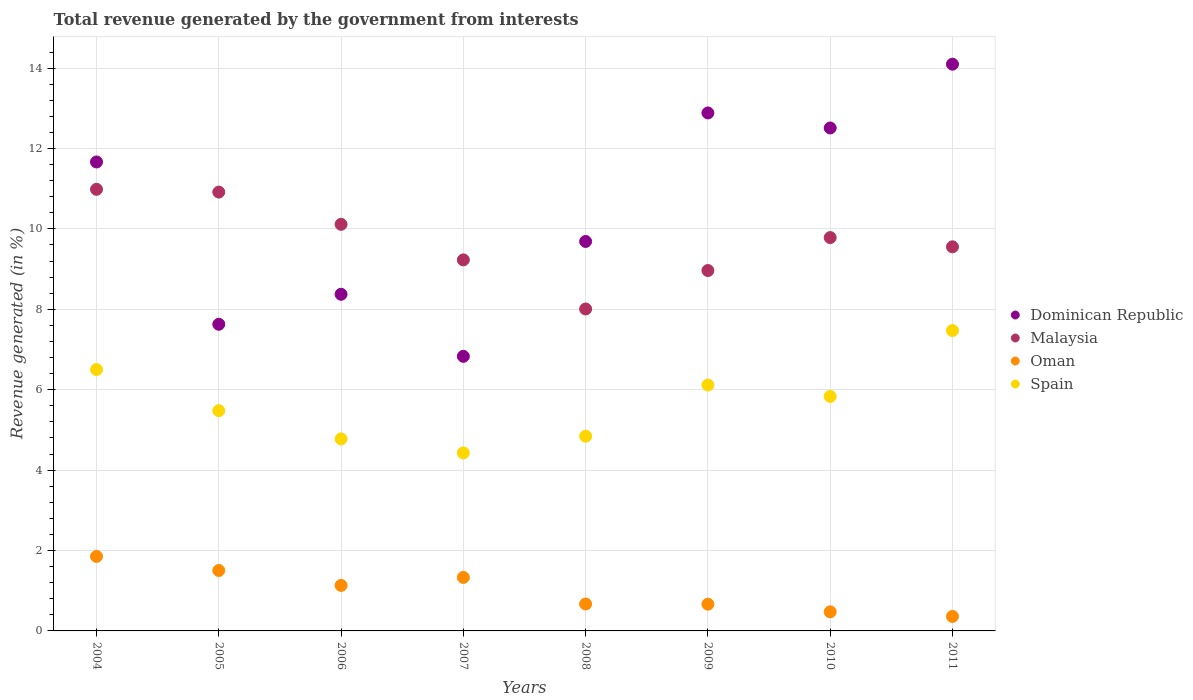How many different coloured dotlines are there?
Give a very brief answer. 4. What is the total revenue generated in Dominican Republic in 2009?
Offer a very short reply. 12.88. Across all years, what is the maximum total revenue generated in Oman?
Your answer should be compact. 1.85. Across all years, what is the minimum total revenue generated in Malaysia?
Provide a succinct answer. 8.01. What is the total total revenue generated in Dominican Republic in the graph?
Offer a terse response. 83.68. What is the difference between the total revenue generated in Dominican Republic in 2005 and that in 2011?
Your answer should be very brief. -6.47. What is the difference between the total revenue generated in Spain in 2006 and the total revenue generated in Malaysia in 2008?
Ensure brevity in your answer.  -3.23. What is the average total revenue generated in Oman per year?
Provide a succinct answer. 1. In the year 2008, what is the difference between the total revenue generated in Malaysia and total revenue generated in Spain?
Give a very brief answer. 3.16. What is the ratio of the total revenue generated in Spain in 2004 to that in 2008?
Offer a very short reply. 1.34. Is the total revenue generated in Spain in 2004 less than that in 2010?
Keep it short and to the point. No. Is the difference between the total revenue generated in Malaysia in 2006 and 2011 greater than the difference between the total revenue generated in Spain in 2006 and 2011?
Provide a succinct answer. Yes. What is the difference between the highest and the second highest total revenue generated in Dominican Republic?
Your answer should be compact. 1.21. What is the difference between the highest and the lowest total revenue generated in Spain?
Keep it short and to the point. 3.04. In how many years, is the total revenue generated in Spain greater than the average total revenue generated in Spain taken over all years?
Offer a very short reply. 4. How many dotlines are there?
Your response must be concise. 4. What is the difference between two consecutive major ticks on the Y-axis?
Provide a short and direct response. 2. Does the graph contain grids?
Your response must be concise. Yes. Where does the legend appear in the graph?
Ensure brevity in your answer.  Center right. How many legend labels are there?
Provide a short and direct response. 4. How are the legend labels stacked?
Ensure brevity in your answer.  Vertical. What is the title of the graph?
Make the answer very short. Total revenue generated by the government from interests. Does "Nicaragua" appear as one of the legend labels in the graph?
Ensure brevity in your answer.  No. What is the label or title of the Y-axis?
Provide a succinct answer. Revenue generated (in %). What is the Revenue generated (in %) in Dominican Republic in 2004?
Offer a terse response. 11.67. What is the Revenue generated (in %) of Malaysia in 2004?
Offer a very short reply. 10.99. What is the Revenue generated (in %) of Oman in 2004?
Provide a succinct answer. 1.85. What is the Revenue generated (in %) of Spain in 2004?
Provide a succinct answer. 6.5. What is the Revenue generated (in %) of Dominican Republic in 2005?
Offer a very short reply. 7.63. What is the Revenue generated (in %) in Malaysia in 2005?
Provide a short and direct response. 10.92. What is the Revenue generated (in %) of Oman in 2005?
Your answer should be compact. 1.5. What is the Revenue generated (in %) of Spain in 2005?
Your response must be concise. 5.48. What is the Revenue generated (in %) in Dominican Republic in 2006?
Your response must be concise. 8.37. What is the Revenue generated (in %) of Malaysia in 2006?
Provide a short and direct response. 10.11. What is the Revenue generated (in %) in Oman in 2006?
Keep it short and to the point. 1.13. What is the Revenue generated (in %) in Spain in 2006?
Keep it short and to the point. 4.78. What is the Revenue generated (in %) in Dominican Republic in 2007?
Ensure brevity in your answer.  6.83. What is the Revenue generated (in %) of Malaysia in 2007?
Keep it short and to the point. 9.23. What is the Revenue generated (in %) in Oman in 2007?
Provide a short and direct response. 1.33. What is the Revenue generated (in %) in Spain in 2007?
Your answer should be compact. 4.43. What is the Revenue generated (in %) in Dominican Republic in 2008?
Keep it short and to the point. 9.69. What is the Revenue generated (in %) of Malaysia in 2008?
Your answer should be compact. 8.01. What is the Revenue generated (in %) of Oman in 2008?
Keep it short and to the point. 0.67. What is the Revenue generated (in %) in Spain in 2008?
Offer a very short reply. 4.84. What is the Revenue generated (in %) of Dominican Republic in 2009?
Provide a succinct answer. 12.88. What is the Revenue generated (in %) in Malaysia in 2009?
Give a very brief answer. 8.96. What is the Revenue generated (in %) of Oman in 2009?
Your answer should be compact. 0.66. What is the Revenue generated (in %) of Spain in 2009?
Your answer should be compact. 6.12. What is the Revenue generated (in %) of Dominican Republic in 2010?
Your answer should be compact. 12.51. What is the Revenue generated (in %) in Malaysia in 2010?
Your answer should be compact. 9.78. What is the Revenue generated (in %) in Oman in 2010?
Provide a short and direct response. 0.47. What is the Revenue generated (in %) in Spain in 2010?
Give a very brief answer. 5.83. What is the Revenue generated (in %) in Dominican Republic in 2011?
Offer a very short reply. 14.1. What is the Revenue generated (in %) of Malaysia in 2011?
Make the answer very short. 9.55. What is the Revenue generated (in %) of Oman in 2011?
Ensure brevity in your answer.  0.36. What is the Revenue generated (in %) of Spain in 2011?
Offer a very short reply. 7.47. Across all years, what is the maximum Revenue generated (in %) of Dominican Republic?
Offer a terse response. 14.1. Across all years, what is the maximum Revenue generated (in %) in Malaysia?
Provide a succinct answer. 10.99. Across all years, what is the maximum Revenue generated (in %) in Oman?
Give a very brief answer. 1.85. Across all years, what is the maximum Revenue generated (in %) of Spain?
Offer a very short reply. 7.47. Across all years, what is the minimum Revenue generated (in %) of Dominican Republic?
Make the answer very short. 6.83. Across all years, what is the minimum Revenue generated (in %) in Malaysia?
Provide a short and direct response. 8.01. Across all years, what is the minimum Revenue generated (in %) of Oman?
Give a very brief answer. 0.36. Across all years, what is the minimum Revenue generated (in %) in Spain?
Provide a short and direct response. 4.43. What is the total Revenue generated (in %) of Dominican Republic in the graph?
Your response must be concise. 83.68. What is the total Revenue generated (in %) of Malaysia in the graph?
Give a very brief answer. 77.56. What is the total Revenue generated (in %) of Oman in the graph?
Make the answer very short. 7.99. What is the total Revenue generated (in %) in Spain in the graph?
Your response must be concise. 45.45. What is the difference between the Revenue generated (in %) of Dominican Republic in 2004 and that in 2005?
Provide a succinct answer. 4.04. What is the difference between the Revenue generated (in %) in Malaysia in 2004 and that in 2005?
Make the answer very short. 0.07. What is the difference between the Revenue generated (in %) in Oman in 2004 and that in 2005?
Keep it short and to the point. 0.35. What is the difference between the Revenue generated (in %) in Spain in 2004 and that in 2005?
Keep it short and to the point. 1.02. What is the difference between the Revenue generated (in %) of Dominican Republic in 2004 and that in 2006?
Offer a terse response. 3.29. What is the difference between the Revenue generated (in %) in Malaysia in 2004 and that in 2006?
Your answer should be compact. 0.87. What is the difference between the Revenue generated (in %) in Oman in 2004 and that in 2006?
Provide a short and direct response. 0.72. What is the difference between the Revenue generated (in %) in Spain in 2004 and that in 2006?
Provide a short and direct response. 1.73. What is the difference between the Revenue generated (in %) of Dominican Republic in 2004 and that in 2007?
Your answer should be very brief. 4.83. What is the difference between the Revenue generated (in %) of Malaysia in 2004 and that in 2007?
Your answer should be compact. 1.76. What is the difference between the Revenue generated (in %) in Oman in 2004 and that in 2007?
Your response must be concise. 0.52. What is the difference between the Revenue generated (in %) in Spain in 2004 and that in 2007?
Keep it short and to the point. 2.07. What is the difference between the Revenue generated (in %) in Dominican Republic in 2004 and that in 2008?
Offer a very short reply. 1.98. What is the difference between the Revenue generated (in %) of Malaysia in 2004 and that in 2008?
Offer a terse response. 2.98. What is the difference between the Revenue generated (in %) in Oman in 2004 and that in 2008?
Provide a succinct answer. 1.18. What is the difference between the Revenue generated (in %) in Spain in 2004 and that in 2008?
Make the answer very short. 1.66. What is the difference between the Revenue generated (in %) in Dominican Republic in 2004 and that in 2009?
Your answer should be very brief. -1.22. What is the difference between the Revenue generated (in %) of Malaysia in 2004 and that in 2009?
Provide a short and direct response. 2.02. What is the difference between the Revenue generated (in %) of Oman in 2004 and that in 2009?
Keep it short and to the point. 1.19. What is the difference between the Revenue generated (in %) of Spain in 2004 and that in 2009?
Provide a succinct answer. 0.38. What is the difference between the Revenue generated (in %) of Dominican Republic in 2004 and that in 2010?
Provide a short and direct response. -0.85. What is the difference between the Revenue generated (in %) in Malaysia in 2004 and that in 2010?
Provide a succinct answer. 1.2. What is the difference between the Revenue generated (in %) of Oman in 2004 and that in 2010?
Provide a short and direct response. 1.38. What is the difference between the Revenue generated (in %) of Spain in 2004 and that in 2010?
Provide a short and direct response. 0.67. What is the difference between the Revenue generated (in %) in Dominican Republic in 2004 and that in 2011?
Provide a short and direct response. -2.43. What is the difference between the Revenue generated (in %) of Malaysia in 2004 and that in 2011?
Keep it short and to the point. 1.43. What is the difference between the Revenue generated (in %) of Oman in 2004 and that in 2011?
Provide a short and direct response. 1.49. What is the difference between the Revenue generated (in %) in Spain in 2004 and that in 2011?
Offer a very short reply. -0.97. What is the difference between the Revenue generated (in %) of Dominican Republic in 2005 and that in 2006?
Provide a succinct answer. -0.75. What is the difference between the Revenue generated (in %) of Malaysia in 2005 and that in 2006?
Give a very brief answer. 0.8. What is the difference between the Revenue generated (in %) of Oman in 2005 and that in 2006?
Your answer should be very brief. 0.37. What is the difference between the Revenue generated (in %) in Spain in 2005 and that in 2006?
Provide a succinct answer. 0.7. What is the difference between the Revenue generated (in %) of Dominican Republic in 2005 and that in 2007?
Your answer should be very brief. 0.8. What is the difference between the Revenue generated (in %) in Malaysia in 2005 and that in 2007?
Ensure brevity in your answer.  1.69. What is the difference between the Revenue generated (in %) of Oman in 2005 and that in 2007?
Provide a short and direct response. 0.17. What is the difference between the Revenue generated (in %) in Spain in 2005 and that in 2007?
Provide a succinct answer. 1.05. What is the difference between the Revenue generated (in %) of Dominican Republic in 2005 and that in 2008?
Make the answer very short. -2.06. What is the difference between the Revenue generated (in %) of Malaysia in 2005 and that in 2008?
Your response must be concise. 2.91. What is the difference between the Revenue generated (in %) in Oman in 2005 and that in 2008?
Keep it short and to the point. 0.83. What is the difference between the Revenue generated (in %) in Spain in 2005 and that in 2008?
Offer a terse response. 0.63. What is the difference between the Revenue generated (in %) in Dominican Republic in 2005 and that in 2009?
Offer a very short reply. -5.26. What is the difference between the Revenue generated (in %) in Malaysia in 2005 and that in 2009?
Keep it short and to the point. 1.95. What is the difference between the Revenue generated (in %) in Oman in 2005 and that in 2009?
Offer a very short reply. 0.84. What is the difference between the Revenue generated (in %) of Spain in 2005 and that in 2009?
Provide a short and direct response. -0.64. What is the difference between the Revenue generated (in %) in Dominican Republic in 2005 and that in 2010?
Ensure brevity in your answer.  -4.88. What is the difference between the Revenue generated (in %) of Malaysia in 2005 and that in 2010?
Your answer should be very brief. 1.13. What is the difference between the Revenue generated (in %) of Oman in 2005 and that in 2010?
Offer a terse response. 1.03. What is the difference between the Revenue generated (in %) in Spain in 2005 and that in 2010?
Offer a terse response. -0.35. What is the difference between the Revenue generated (in %) in Dominican Republic in 2005 and that in 2011?
Your answer should be very brief. -6.47. What is the difference between the Revenue generated (in %) in Malaysia in 2005 and that in 2011?
Give a very brief answer. 1.36. What is the difference between the Revenue generated (in %) in Oman in 2005 and that in 2011?
Your answer should be very brief. 1.14. What is the difference between the Revenue generated (in %) in Spain in 2005 and that in 2011?
Offer a terse response. -1.99. What is the difference between the Revenue generated (in %) in Dominican Republic in 2006 and that in 2007?
Keep it short and to the point. 1.54. What is the difference between the Revenue generated (in %) in Malaysia in 2006 and that in 2007?
Your answer should be compact. 0.88. What is the difference between the Revenue generated (in %) of Oman in 2006 and that in 2007?
Offer a very short reply. -0.2. What is the difference between the Revenue generated (in %) of Spain in 2006 and that in 2007?
Ensure brevity in your answer.  0.35. What is the difference between the Revenue generated (in %) in Dominican Republic in 2006 and that in 2008?
Your answer should be very brief. -1.31. What is the difference between the Revenue generated (in %) of Malaysia in 2006 and that in 2008?
Your response must be concise. 2.11. What is the difference between the Revenue generated (in %) of Oman in 2006 and that in 2008?
Make the answer very short. 0.46. What is the difference between the Revenue generated (in %) in Spain in 2006 and that in 2008?
Provide a short and direct response. -0.07. What is the difference between the Revenue generated (in %) of Dominican Republic in 2006 and that in 2009?
Provide a succinct answer. -4.51. What is the difference between the Revenue generated (in %) in Malaysia in 2006 and that in 2009?
Keep it short and to the point. 1.15. What is the difference between the Revenue generated (in %) in Oman in 2006 and that in 2009?
Provide a short and direct response. 0.47. What is the difference between the Revenue generated (in %) in Spain in 2006 and that in 2009?
Make the answer very short. -1.34. What is the difference between the Revenue generated (in %) of Dominican Republic in 2006 and that in 2010?
Keep it short and to the point. -4.14. What is the difference between the Revenue generated (in %) in Malaysia in 2006 and that in 2010?
Provide a short and direct response. 0.33. What is the difference between the Revenue generated (in %) in Oman in 2006 and that in 2010?
Ensure brevity in your answer.  0.66. What is the difference between the Revenue generated (in %) in Spain in 2006 and that in 2010?
Give a very brief answer. -1.06. What is the difference between the Revenue generated (in %) of Dominican Republic in 2006 and that in 2011?
Your answer should be very brief. -5.72. What is the difference between the Revenue generated (in %) in Malaysia in 2006 and that in 2011?
Provide a short and direct response. 0.56. What is the difference between the Revenue generated (in %) of Oman in 2006 and that in 2011?
Offer a very short reply. 0.77. What is the difference between the Revenue generated (in %) in Spain in 2006 and that in 2011?
Provide a short and direct response. -2.7. What is the difference between the Revenue generated (in %) in Dominican Republic in 2007 and that in 2008?
Your response must be concise. -2.86. What is the difference between the Revenue generated (in %) in Malaysia in 2007 and that in 2008?
Keep it short and to the point. 1.22. What is the difference between the Revenue generated (in %) in Oman in 2007 and that in 2008?
Provide a succinct answer. 0.66. What is the difference between the Revenue generated (in %) of Spain in 2007 and that in 2008?
Give a very brief answer. -0.42. What is the difference between the Revenue generated (in %) of Dominican Republic in 2007 and that in 2009?
Your answer should be very brief. -6.05. What is the difference between the Revenue generated (in %) in Malaysia in 2007 and that in 2009?
Provide a succinct answer. 0.26. What is the difference between the Revenue generated (in %) in Oman in 2007 and that in 2009?
Provide a succinct answer. 0.67. What is the difference between the Revenue generated (in %) in Spain in 2007 and that in 2009?
Offer a terse response. -1.69. What is the difference between the Revenue generated (in %) in Dominican Republic in 2007 and that in 2010?
Make the answer very short. -5.68. What is the difference between the Revenue generated (in %) in Malaysia in 2007 and that in 2010?
Provide a short and direct response. -0.55. What is the difference between the Revenue generated (in %) in Oman in 2007 and that in 2010?
Ensure brevity in your answer.  0.86. What is the difference between the Revenue generated (in %) in Spain in 2007 and that in 2010?
Provide a short and direct response. -1.4. What is the difference between the Revenue generated (in %) in Dominican Republic in 2007 and that in 2011?
Offer a very short reply. -7.27. What is the difference between the Revenue generated (in %) of Malaysia in 2007 and that in 2011?
Offer a terse response. -0.33. What is the difference between the Revenue generated (in %) in Oman in 2007 and that in 2011?
Give a very brief answer. 0.97. What is the difference between the Revenue generated (in %) in Spain in 2007 and that in 2011?
Your response must be concise. -3.04. What is the difference between the Revenue generated (in %) of Dominican Republic in 2008 and that in 2009?
Your answer should be very brief. -3.2. What is the difference between the Revenue generated (in %) of Malaysia in 2008 and that in 2009?
Provide a succinct answer. -0.96. What is the difference between the Revenue generated (in %) in Oman in 2008 and that in 2009?
Give a very brief answer. 0.01. What is the difference between the Revenue generated (in %) of Spain in 2008 and that in 2009?
Offer a terse response. -1.27. What is the difference between the Revenue generated (in %) of Dominican Republic in 2008 and that in 2010?
Your answer should be compact. -2.82. What is the difference between the Revenue generated (in %) in Malaysia in 2008 and that in 2010?
Ensure brevity in your answer.  -1.78. What is the difference between the Revenue generated (in %) of Oman in 2008 and that in 2010?
Your answer should be very brief. 0.2. What is the difference between the Revenue generated (in %) in Spain in 2008 and that in 2010?
Ensure brevity in your answer.  -0.99. What is the difference between the Revenue generated (in %) in Dominican Republic in 2008 and that in 2011?
Offer a terse response. -4.41. What is the difference between the Revenue generated (in %) in Malaysia in 2008 and that in 2011?
Your answer should be very brief. -1.55. What is the difference between the Revenue generated (in %) in Oman in 2008 and that in 2011?
Your answer should be very brief. 0.31. What is the difference between the Revenue generated (in %) in Spain in 2008 and that in 2011?
Provide a succinct answer. -2.63. What is the difference between the Revenue generated (in %) of Dominican Republic in 2009 and that in 2010?
Your answer should be very brief. 0.37. What is the difference between the Revenue generated (in %) of Malaysia in 2009 and that in 2010?
Give a very brief answer. -0.82. What is the difference between the Revenue generated (in %) of Oman in 2009 and that in 2010?
Offer a terse response. 0.19. What is the difference between the Revenue generated (in %) of Spain in 2009 and that in 2010?
Keep it short and to the point. 0.28. What is the difference between the Revenue generated (in %) of Dominican Republic in 2009 and that in 2011?
Make the answer very short. -1.21. What is the difference between the Revenue generated (in %) of Malaysia in 2009 and that in 2011?
Your response must be concise. -0.59. What is the difference between the Revenue generated (in %) in Oman in 2009 and that in 2011?
Offer a very short reply. 0.3. What is the difference between the Revenue generated (in %) in Spain in 2009 and that in 2011?
Offer a terse response. -1.35. What is the difference between the Revenue generated (in %) in Dominican Republic in 2010 and that in 2011?
Ensure brevity in your answer.  -1.59. What is the difference between the Revenue generated (in %) of Malaysia in 2010 and that in 2011?
Give a very brief answer. 0.23. What is the difference between the Revenue generated (in %) in Oman in 2010 and that in 2011?
Offer a terse response. 0.11. What is the difference between the Revenue generated (in %) in Spain in 2010 and that in 2011?
Make the answer very short. -1.64. What is the difference between the Revenue generated (in %) in Dominican Republic in 2004 and the Revenue generated (in %) in Malaysia in 2005?
Your answer should be compact. 0.75. What is the difference between the Revenue generated (in %) of Dominican Republic in 2004 and the Revenue generated (in %) of Oman in 2005?
Provide a succinct answer. 10.16. What is the difference between the Revenue generated (in %) of Dominican Republic in 2004 and the Revenue generated (in %) of Spain in 2005?
Give a very brief answer. 6.19. What is the difference between the Revenue generated (in %) in Malaysia in 2004 and the Revenue generated (in %) in Oman in 2005?
Provide a succinct answer. 9.48. What is the difference between the Revenue generated (in %) of Malaysia in 2004 and the Revenue generated (in %) of Spain in 2005?
Offer a very short reply. 5.51. What is the difference between the Revenue generated (in %) in Oman in 2004 and the Revenue generated (in %) in Spain in 2005?
Make the answer very short. -3.63. What is the difference between the Revenue generated (in %) of Dominican Republic in 2004 and the Revenue generated (in %) of Malaysia in 2006?
Your answer should be very brief. 1.55. What is the difference between the Revenue generated (in %) in Dominican Republic in 2004 and the Revenue generated (in %) in Oman in 2006?
Your answer should be very brief. 10.53. What is the difference between the Revenue generated (in %) in Dominican Republic in 2004 and the Revenue generated (in %) in Spain in 2006?
Offer a very short reply. 6.89. What is the difference between the Revenue generated (in %) in Malaysia in 2004 and the Revenue generated (in %) in Oman in 2006?
Provide a succinct answer. 9.85. What is the difference between the Revenue generated (in %) in Malaysia in 2004 and the Revenue generated (in %) in Spain in 2006?
Offer a terse response. 6.21. What is the difference between the Revenue generated (in %) of Oman in 2004 and the Revenue generated (in %) of Spain in 2006?
Ensure brevity in your answer.  -2.92. What is the difference between the Revenue generated (in %) in Dominican Republic in 2004 and the Revenue generated (in %) in Malaysia in 2007?
Your answer should be very brief. 2.44. What is the difference between the Revenue generated (in %) of Dominican Republic in 2004 and the Revenue generated (in %) of Oman in 2007?
Offer a terse response. 10.33. What is the difference between the Revenue generated (in %) in Dominican Republic in 2004 and the Revenue generated (in %) in Spain in 2007?
Your answer should be very brief. 7.24. What is the difference between the Revenue generated (in %) of Malaysia in 2004 and the Revenue generated (in %) of Oman in 2007?
Provide a succinct answer. 9.65. What is the difference between the Revenue generated (in %) of Malaysia in 2004 and the Revenue generated (in %) of Spain in 2007?
Ensure brevity in your answer.  6.56. What is the difference between the Revenue generated (in %) of Oman in 2004 and the Revenue generated (in %) of Spain in 2007?
Offer a very short reply. -2.57. What is the difference between the Revenue generated (in %) of Dominican Republic in 2004 and the Revenue generated (in %) of Malaysia in 2008?
Offer a terse response. 3.66. What is the difference between the Revenue generated (in %) of Dominican Republic in 2004 and the Revenue generated (in %) of Oman in 2008?
Give a very brief answer. 11. What is the difference between the Revenue generated (in %) in Dominican Republic in 2004 and the Revenue generated (in %) in Spain in 2008?
Offer a very short reply. 6.82. What is the difference between the Revenue generated (in %) of Malaysia in 2004 and the Revenue generated (in %) of Oman in 2008?
Keep it short and to the point. 10.32. What is the difference between the Revenue generated (in %) of Malaysia in 2004 and the Revenue generated (in %) of Spain in 2008?
Give a very brief answer. 6.14. What is the difference between the Revenue generated (in %) of Oman in 2004 and the Revenue generated (in %) of Spain in 2008?
Keep it short and to the point. -2.99. What is the difference between the Revenue generated (in %) of Dominican Republic in 2004 and the Revenue generated (in %) of Malaysia in 2009?
Keep it short and to the point. 2.7. What is the difference between the Revenue generated (in %) of Dominican Republic in 2004 and the Revenue generated (in %) of Oman in 2009?
Offer a terse response. 11. What is the difference between the Revenue generated (in %) of Dominican Republic in 2004 and the Revenue generated (in %) of Spain in 2009?
Provide a short and direct response. 5.55. What is the difference between the Revenue generated (in %) of Malaysia in 2004 and the Revenue generated (in %) of Oman in 2009?
Ensure brevity in your answer.  10.32. What is the difference between the Revenue generated (in %) of Malaysia in 2004 and the Revenue generated (in %) of Spain in 2009?
Keep it short and to the point. 4.87. What is the difference between the Revenue generated (in %) of Oman in 2004 and the Revenue generated (in %) of Spain in 2009?
Your response must be concise. -4.26. What is the difference between the Revenue generated (in %) in Dominican Republic in 2004 and the Revenue generated (in %) in Malaysia in 2010?
Your response must be concise. 1.88. What is the difference between the Revenue generated (in %) of Dominican Republic in 2004 and the Revenue generated (in %) of Oman in 2010?
Make the answer very short. 11.19. What is the difference between the Revenue generated (in %) of Dominican Republic in 2004 and the Revenue generated (in %) of Spain in 2010?
Ensure brevity in your answer.  5.83. What is the difference between the Revenue generated (in %) in Malaysia in 2004 and the Revenue generated (in %) in Oman in 2010?
Offer a terse response. 10.51. What is the difference between the Revenue generated (in %) of Malaysia in 2004 and the Revenue generated (in %) of Spain in 2010?
Your answer should be compact. 5.15. What is the difference between the Revenue generated (in %) in Oman in 2004 and the Revenue generated (in %) in Spain in 2010?
Make the answer very short. -3.98. What is the difference between the Revenue generated (in %) in Dominican Republic in 2004 and the Revenue generated (in %) in Malaysia in 2011?
Provide a succinct answer. 2.11. What is the difference between the Revenue generated (in %) of Dominican Republic in 2004 and the Revenue generated (in %) of Oman in 2011?
Offer a very short reply. 11.31. What is the difference between the Revenue generated (in %) of Dominican Republic in 2004 and the Revenue generated (in %) of Spain in 2011?
Provide a short and direct response. 4.19. What is the difference between the Revenue generated (in %) in Malaysia in 2004 and the Revenue generated (in %) in Oman in 2011?
Make the answer very short. 10.63. What is the difference between the Revenue generated (in %) in Malaysia in 2004 and the Revenue generated (in %) in Spain in 2011?
Provide a short and direct response. 3.51. What is the difference between the Revenue generated (in %) in Oman in 2004 and the Revenue generated (in %) in Spain in 2011?
Offer a terse response. -5.62. What is the difference between the Revenue generated (in %) of Dominican Republic in 2005 and the Revenue generated (in %) of Malaysia in 2006?
Your answer should be very brief. -2.49. What is the difference between the Revenue generated (in %) of Dominican Republic in 2005 and the Revenue generated (in %) of Oman in 2006?
Offer a terse response. 6.5. What is the difference between the Revenue generated (in %) in Dominican Republic in 2005 and the Revenue generated (in %) in Spain in 2006?
Offer a very short reply. 2.85. What is the difference between the Revenue generated (in %) in Malaysia in 2005 and the Revenue generated (in %) in Oman in 2006?
Make the answer very short. 9.78. What is the difference between the Revenue generated (in %) in Malaysia in 2005 and the Revenue generated (in %) in Spain in 2006?
Ensure brevity in your answer.  6.14. What is the difference between the Revenue generated (in %) in Oman in 2005 and the Revenue generated (in %) in Spain in 2006?
Offer a terse response. -3.27. What is the difference between the Revenue generated (in %) of Dominican Republic in 2005 and the Revenue generated (in %) of Malaysia in 2007?
Your answer should be very brief. -1.6. What is the difference between the Revenue generated (in %) in Dominican Republic in 2005 and the Revenue generated (in %) in Oman in 2007?
Provide a short and direct response. 6.3. What is the difference between the Revenue generated (in %) of Dominican Republic in 2005 and the Revenue generated (in %) of Spain in 2007?
Give a very brief answer. 3.2. What is the difference between the Revenue generated (in %) in Malaysia in 2005 and the Revenue generated (in %) in Oman in 2007?
Your response must be concise. 9.59. What is the difference between the Revenue generated (in %) in Malaysia in 2005 and the Revenue generated (in %) in Spain in 2007?
Offer a very short reply. 6.49. What is the difference between the Revenue generated (in %) in Oman in 2005 and the Revenue generated (in %) in Spain in 2007?
Give a very brief answer. -2.92. What is the difference between the Revenue generated (in %) of Dominican Republic in 2005 and the Revenue generated (in %) of Malaysia in 2008?
Your response must be concise. -0.38. What is the difference between the Revenue generated (in %) in Dominican Republic in 2005 and the Revenue generated (in %) in Oman in 2008?
Offer a terse response. 6.96. What is the difference between the Revenue generated (in %) in Dominican Republic in 2005 and the Revenue generated (in %) in Spain in 2008?
Your response must be concise. 2.78. What is the difference between the Revenue generated (in %) in Malaysia in 2005 and the Revenue generated (in %) in Oman in 2008?
Give a very brief answer. 10.25. What is the difference between the Revenue generated (in %) in Malaysia in 2005 and the Revenue generated (in %) in Spain in 2008?
Provide a succinct answer. 6.07. What is the difference between the Revenue generated (in %) in Oman in 2005 and the Revenue generated (in %) in Spain in 2008?
Offer a very short reply. -3.34. What is the difference between the Revenue generated (in %) of Dominican Republic in 2005 and the Revenue generated (in %) of Malaysia in 2009?
Your response must be concise. -1.34. What is the difference between the Revenue generated (in %) of Dominican Republic in 2005 and the Revenue generated (in %) of Oman in 2009?
Give a very brief answer. 6.96. What is the difference between the Revenue generated (in %) of Dominican Republic in 2005 and the Revenue generated (in %) of Spain in 2009?
Your answer should be very brief. 1.51. What is the difference between the Revenue generated (in %) in Malaysia in 2005 and the Revenue generated (in %) in Oman in 2009?
Provide a succinct answer. 10.25. What is the difference between the Revenue generated (in %) in Malaysia in 2005 and the Revenue generated (in %) in Spain in 2009?
Offer a very short reply. 4.8. What is the difference between the Revenue generated (in %) in Oman in 2005 and the Revenue generated (in %) in Spain in 2009?
Keep it short and to the point. -4.61. What is the difference between the Revenue generated (in %) in Dominican Republic in 2005 and the Revenue generated (in %) in Malaysia in 2010?
Offer a very short reply. -2.16. What is the difference between the Revenue generated (in %) in Dominican Republic in 2005 and the Revenue generated (in %) in Oman in 2010?
Your answer should be very brief. 7.15. What is the difference between the Revenue generated (in %) of Dominican Republic in 2005 and the Revenue generated (in %) of Spain in 2010?
Your answer should be very brief. 1.8. What is the difference between the Revenue generated (in %) in Malaysia in 2005 and the Revenue generated (in %) in Oman in 2010?
Provide a short and direct response. 10.44. What is the difference between the Revenue generated (in %) in Malaysia in 2005 and the Revenue generated (in %) in Spain in 2010?
Provide a short and direct response. 5.08. What is the difference between the Revenue generated (in %) in Oman in 2005 and the Revenue generated (in %) in Spain in 2010?
Give a very brief answer. -4.33. What is the difference between the Revenue generated (in %) in Dominican Republic in 2005 and the Revenue generated (in %) in Malaysia in 2011?
Provide a short and direct response. -1.93. What is the difference between the Revenue generated (in %) of Dominican Republic in 2005 and the Revenue generated (in %) of Oman in 2011?
Keep it short and to the point. 7.27. What is the difference between the Revenue generated (in %) of Dominican Republic in 2005 and the Revenue generated (in %) of Spain in 2011?
Your answer should be compact. 0.16. What is the difference between the Revenue generated (in %) in Malaysia in 2005 and the Revenue generated (in %) in Oman in 2011?
Make the answer very short. 10.56. What is the difference between the Revenue generated (in %) in Malaysia in 2005 and the Revenue generated (in %) in Spain in 2011?
Offer a very short reply. 3.44. What is the difference between the Revenue generated (in %) of Oman in 2005 and the Revenue generated (in %) of Spain in 2011?
Your response must be concise. -5.97. What is the difference between the Revenue generated (in %) of Dominican Republic in 2006 and the Revenue generated (in %) of Malaysia in 2007?
Ensure brevity in your answer.  -0.86. What is the difference between the Revenue generated (in %) of Dominican Republic in 2006 and the Revenue generated (in %) of Oman in 2007?
Make the answer very short. 7.04. What is the difference between the Revenue generated (in %) in Dominican Republic in 2006 and the Revenue generated (in %) in Spain in 2007?
Provide a succinct answer. 3.95. What is the difference between the Revenue generated (in %) of Malaysia in 2006 and the Revenue generated (in %) of Oman in 2007?
Your answer should be compact. 8.78. What is the difference between the Revenue generated (in %) in Malaysia in 2006 and the Revenue generated (in %) in Spain in 2007?
Provide a short and direct response. 5.69. What is the difference between the Revenue generated (in %) in Oman in 2006 and the Revenue generated (in %) in Spain in 2007?
Ensure brevity in your answer.  -3.3. What is the difference between the Revenue generated (in %) of Dominican Republic in 2006 and the Revenue generated (in %) of Malaysia in 2008?
Your response must be concise. 0.37. What is the difference between the Revenue generated (in %) in Dominican Republic in 2006 and the Revenue generated (in %) in Oman in 2008?
Offer a very short reply. 7.7. What is the difference between the Revenue generated (in %) of Dominican Republic in 2006 and the Revenue generated (in %) of Spain in 2008?
Give a very brief answer. 3.53. What is the difference between the Revenue generated (in %) of Malaysia in 2006 and the Revenue generated (in %) of Oman in 2008?
Give a very brief answer. 9.44. What is the difference between the Revenue generated (in %) of Malaysia in 2006 and the Revenue generated (in %) of Spain in 2008?
Ensure brevity in your answer.  5.27. What is the difference between the Revenue generated (in %) in Oman in 2006 and the Revenue generated (in %) in Spain in 2008?
Offer a very short reply. -3.71. What is the difference between the Revenue generated (in %) of Dominican Republic in 2006 and the Revenue generated (in %) of Malaysia in 2009?
Keep it short and to the point. -0.59. What is the difference between the Revenue generated (in %) in Dominican Republic in 2006 and the Revenue generated (in %) in Oman in 2009?
Make the answer very short. 7.71. What is the difference between the Revenue generated (in %) of Dominican Republic in 2006 and the Revenue generated (in %) of Spain in 2009?
Offer a very short reply. 2.26. What is the difference between the Revenue generated (in %) of Malaysia in 2006 and the Revenue generated (in %) of Oman in 2009?
Your answer should be compact. 9.45. What is the difference between the Revenue generated (in %) in Malaysia in 2006 and the Revenue generated (in %) in Spain in 2009?
Offer a very short reply. 4. What is the difference between the Revenue generated (in %) in Oman in 2006 and the Revenue generated (in %) in Spain in 2009?
Your answer should be compact. -4.99. What is the difference between the Revenue generated (in %) of Dominican Republic in 2006 and the Revenue generated (in %) of Malaysia in 2010?
Your answer should be very brief. -1.41. What is the difference between the Revenue generated (in %) in Dominican Republic in 2006 and the Revenue generated (in %) in Oman in 2010?
Keep it short and to the point. 7.9. What is the difference between the Revenue generated (in %) of Dominican Republic in 2006 and the Revenue generated (in %) of Spain in 2010?
Provide a succinct answer. 2.54. What is the difference between the Revenue generated (in %) of Malaysia in 2006 and the Revenue generated (in %) of Oman in 2010?
Provide a short and direct response. 9.64. What is the difference between the Revenue generated (in %) of Malaysia in 2006 and the Revenue generated (in %) of Spain in 2010?
Give a very brief answer. 4.28. What is the difference between the Revenue generated (in %) of Oman in 2006 and the Revenue generated (in %) of Spain in 2010?
Your answer should be compact. -4.7. What is the difference between the Revenue generated (in %) of Dominican Republic in 2006 and the Revenue generated (in %) of Malaysia in 2011?
Offer a very short reply. -1.18. What is the difference between the Revenue generated (in %) of Dominican Republic in 2006 and the Revenue generated (in %) of Oman in 2011?
Provide a succinct answer. 8.01. What is the difference between the Revenue generated (in %) in Dominican Republic in 2006 and the Revenue generated (in %) in Spain in 2011?
Your response must be concise. 0.9. What is the difference between the Revenue generated (in %) of Malaysia in 2006 and the Revenue generated (in %) of Oman in 2011?
Make the answer very short. 9.75. What is the difference between the Revenue generated (in %) of Malaysia in 2006 and the Revenue generated (in %) of Spain in 2011?
Keep it short and to the point. 2.64. What is the difference between the Revenue generated (in %) of Oman in 2006 and the Revenue generated (in %) of Spain in 2011?
Keep it short and to the point. -6.34. What is the difference between the Revenue generated (in %) in Dominican Republic in 2007 and the Revenue generated (in %) in Malaysia in 2008?
Provide a succinct answer. -1.18. What is the difference between the Revenue generated (in %) of Dominican Republic in 2007 and the Revenue generated (in %) of Oman in 2008?
Provide a short and direct response. 6.16. What is the difference between the Revenue generated (in %) of Dominican Republic in 2007 and the Revenue generated (in %) of Spain in 2008?
Provide a succinct answer. 1.99. What is the difference between the Revenue generated (in %) of Malaysia in 2007 and the Revenue generated (in %) of Oman in 2008?
Your answer should be compact. 8.56. What is the difference between the Revenue generated (in %) of Malaysia in 2007 and the Revenue generated (in %) of Spain in 2008?
Offer a very short reply. 4.39. What is the difference between the Revenue generated (in %) of Oman in 2007 and the Revenue generated (in %) of Spain in 2008?
Make the answer very short. -3.51. What is the difference between the Revenue generated (in %) of Dominican Republic in 2007 and the Revenue generated (in %) of Malaysia in 2009?
Offer a very short reply. -2.13. What is the difference between the Revenue generated (in %) of Dominican Republic in 2007 and the Revenue generated (in %) of Oman in 2009?
Provide a short and direct response. 6.17. What is the difference between the Revenue generated (in %) in Dominican Republic in 2007 and the Revenue generated (in %) in Spain in 2009?
Your answer should be very brief. 0.71. What is the difference between the Revenue generated (in %) in Malaysia in 2007 and the Revenue generated (in %) in Oman in 2009?
Provide a short and direct response. 8.56. What is the difference between the Revenue generated (in %) of Malaysia in 2007 and the Revenue generated (in %) of Spain in 2009?
Offer a terse response. 3.11. What is the difference between the Revenue generated (in %) in Oman in 2007 and the Revenue generated (in %) in Spain in 2009?
Your answer should be very brief. -4.79. What is the difference between the Revenue generated (in %) in Dominican Republic in 2007 and the Revenue generated (in %) in Malaysia in 2010?
Provide a short and direct response. -2.95. What is the difference between the Revenue generated (in %) of Dominican Republic in 2007 and the Revenue generated (in %) of Oman in 2010?
Offer a terse response. 6.36. What is the difference between the Revenue generated (in %) of Dominican Republic in 2007 and the Revenue generated (in %) of Spain in 2010?
Keep it short and to the point. 1. What is the difference between the Revenue generated (in %) in Malaysia in 2007 and the Revenue generated (in %) in Oman in 2010?
Offer a terse response. 8.75. What is the difference between the Revenue generated (in %) in Malaysia in 2007 and the Revenue generated (in %) in Spain in 2010?
Your answer should be very brief. 3.4. What is the difference between the Revenue generated (in %) of Oman in 2007 and the Revenue generated (in %) of Spain in 2010?
Your answer should be compact. -4.5. What is the difference between the Revenue generated (in %) of Dominican Republic in 2007 and the Revenue generated (in %) of Malaysia in 2011?
Provide a short and direct response. -2.72. What is the difference between the Revenue generated (in %) of Dominican Republic in 2007 and the Revenue generated (in %) of Oman in 2011?
Offer a very short reply. 6.47. What is the difference between the Revenue generated (in %) of Dominican Republic in 2007 and the Revenue generated (in %) of Spain in 2011?
Make the answer very short. -0.64. What is the difference between the Revenue generated (in %) in Malaysia in 2007 and the Revenue generated (in %) in Oman in 2011?
Offer a very short reply. 8.87. What is the difference between the Revenue generated (in %) in Malaysia in 2007 and the Revenue generated (in %) in Spain in 2011?
Ensure brevity in your answer.  1.76. What is the difference between the Revenue generated (in %) in Oman in 2007 and the Revenue generated (in %) in Spain in 2011?
Provide a succinct answer. -6.14. What is the difference between the Revenue generated (in %) in Dominican Republic in 2008 and the Revenue generated (in %) in Malaysia in 2009?
Your answer should be compact. 0.72. What is the difference between the Revenue generated (in %) of Dominican Republic in 2008 and the Revenue generated (in %) of Oman in 2009?
Ensure brevity in your answer.  9.02. What is the difference between the Revenue generated (in %) of Dominican Republic in 2008 and the Revenue generated (in %) of Spain in 2009?
Provide a short and direct response. 3.57. What is the difference between the Revenue generated (in %) in Malaysia in 2008 and the Revenue generated (in %) in Oman in 2009?
Offer a terse response. 7.34. What is the difference between the Revenue generated (in %) of Malaysia in 2008 and the Revenue generated (in %) of Spain in 2009?
Your response must be concise. 1.89. What is the difference between the Revenue generated (in %) in Oman in 2008 and the Revenue generated (in %) in Spain in 2009?
Your response must be concise. -5.45. What is the difference between the Revenue generated (in %) of Dominican Republic in 2008 and the Revenue generated (in %) of Malaysia in 2010?
Give a very brief answer. -0.1. What is the difference between the Revenue generated (in %) in Dominican Republic in 2008 and the Revenue generated (in %) in Oman in 2010?
Give a very brief answer. 9.21. What is the difference between the Revenue generated (in %) of Dominican Republic in 2008 and the Revenue generated (in %) of Spain in 2010?
Offer a terse response. 3.86. What is the difference between the Revenue generated (in %) of Malaysia in 2008 and the Revenue generated (in %) of Oman in 2010?
Give a very brief answer. 7.53. What is the difference between the Revenue generated (in %) of Malaysia in 2008 and the Revenue generated (in %) of Spain in 2010?
Provide a succinct answer. 2.18. What is the difference between the Revenue generated (in %) in Oman in 2008 and the Revenue generated (in %) in Spain in 2010?
Your response must be concise. -5.16. What is the difference between the Revenue generated (in %) of Dominican Republic in 2008 and the Revenue generated (in %) of Malaysia in 2011?
Your answer should be compact. 0.13. What is the difference between the Revenue generated (in %) in Dominican Republic in 2008 and the Revenue generated (in %) in Oman in 2011?
Provide a short and direct response. 9.33. What is the difference between the Revenue generated (in %) in Dominican Republic in 2008 and the Revenue generated (in %) in Spain in 2011?
Provide a succinct answer. 2.22. What is the difference between the Revenue generated (in %) of Malaysia in 2008 and the Revenue generated (in %) of Oman in 2011?
Offer a terse response. 7.65. What is the difference between the Revenue generated (in %) in Malaysia in 2008 and the Revenue generated (in %) in Spain in 2011?
Provide a succinct answer. 0.54. What is the difference between the Revenue generated (in %) in Oman in 2008 and the Revenue generated (in %) in Spain in 2011?
Provide a short and direct response. -6.8. What is the difference between the Revenue generated (in %) in Dominican Republic in 2009 and the Revenue generated (in %) in Malaysia in 2010?
Ensure brevity in your answer.  3.1. What is the difference between the Revenue generated (in %) of Dominican Republic in 2009 and the Revenue generated (in %) of Oman in 2010?
Provide a short and direct response. 12.41. What is the difference between the Revenue generated (in %) in Dominican Republic in 2009 and the Revenue generated (in %) in Spain in 2010?
Your answer should be very brief. 7.05. What is the difference between the Revenue generated (in %) of Malaysia in 2009 and the Revenue generated (in %) of Oman in 2010?
Provide a short and direct response. 8.49. What is the difference between the Revenue generated (in %) in Malaysia in 2009 and the Revenue generated (in %) in Spain in 2010?
Make the answer very short. 3.13. What is the difference between the Revenue generated (in %) in Oman in 2009 and the Revenue generated (in %) in Spain in 2010?
Provide a succinct answer. -5.17. What is the difference between the Revenue generated (in %) in Dominican Republic in 2009 and the Revenue generated (in %) in Malaysia in 2011?
Your answer should be compact. 3.33. What is the difference between the Revenue generated (in %) of Dominican Republic in 2009 and the Revenue generated (in %) of Oman in 2011?
Offer a very short reply. 12.52. What is the difference between the Revenue generated (in %) of Dominican Republic in 2009 and the Revenue generated (in %) of Spain in 2011?
Give a very brief answer. 5.41. What is the difference between the Revenue generated (in %) of Malaysia in 2009 and the Revenue generated (in %) of Oman in 2011?
Keep it short and to the point. 8.6. What is the difference between the Revenue generated (in %) of Malaysia in 2009 and the Revenue generated (in %) of Spain in 2011?
Ensure brevity in your answer.  1.49. What is the difference between the Revenue generated (in %) of Oman in 2009 and the Revenue generated (in %) of Spain in 2011?
Offer a very short reply. -6.81. What is the difference between the Revenue generated (in %) in Dominican Republic in 2010 and the Revenue generated (in %) in Malaysia in 2011?
Provide a short and direct response. 2.96. What is the difference between the Revenue generated (in %) in Dominican Republic in 2010 and the Revenue generated (in %) in Oman in 2011?
Your answer should be compact. 12.15. What is the difference between the Revenue generated (in %) of Dominican Republic in 2010 and the Revenue generated (in %) of Spain in 2011?
Keep it short and to the point. 5.04. What is the difference between the Revenue generated (in %) of Malaysia in 2010 and the Revenue generated (in %) of Oman in 2011?
Provide a short and direct response. 9.42. What is the difference between the Revenue generated (in %) of Malaysia in 2010 and the Revenue generated (in %) of Spain in 2011?
Offer a terse response. 2.31. What is the difference between the Revenue generated (in %) of Oman in 2010 and the Revenue generated (in %) of Spain in 2011?
Your response must be concise. -7. What is the average Revenue generated (in %) of Dominican Republic per year?
Make the answer very short. 10.46. What is the average Revenue generated (in %) in Malaysia per year?
Your answer should be compact. 9.69. What is the average Revenue generated (in %) of Spain per year?
Offer a terse response. 5.68. In the year 2004, what is the difference between the Revenue generated (in %) of Dominican Republic and Revenue generated (in %) of Malaysia?
Your response must be concise. 0.68. In the year 2004, what is the difference between the Revenue generated (in %) of Dominican Republic and Revenue generated (in %) of Oman?
Provide a succinct answer. 9.81. In the year 2004, what is the difference between the Revenue generated (in %) in Dominican Republic and Revenue generated (in %) in Spain?
Offer a terse response. 5.16. In the year 2004, what is the difference between the Revenue generated (in %) of Malaysia and Revenue generated (in %) of Oman?
Your answer should be very brief. 9.13. In the year 2004, what is the difference between the Revenue generated (in %) of Malaysia and Revenue generated (in %) of Spain?
Your response must be concise. 4.48. In the year 2004, what is the difference between the Revenue generated (in %) in Oman and Revenue generated (in %) in Spain?
Your response must be concise. -4.65. In the year 2005, what is the difference between the Revenue generated (in %) in Dominican Republic and Revenue generated (in %) in Malaysia?
Provide a succinct answer. -3.29. In the year 2005, what is the difference between the Revenue generated (in %) of Dominican Republic and Revenue generated (in %) of Oman?
Ensure brevity in your answer.  6.12. In the year 2005, what is the difference between the Revenue generated (in %) of Dominican Republic and Revenue generated (in %) of Spain?
Provide a short and direct response. 2.15. In the year 2005, what is the difference between the Revenue generated (in %) of Malaysia and Revenue generated (in %) of Oman?
Your answer should be very brief. 9.41. In the year 2005, what is the difference between the Revenue generated (in %) in Malaysia and Revenue generated (in %) in Spain?
Keep it short and to the point. 5.44. In the year 2005, what is the difference between the Revenue generated (in %) in Oman and Revenue generated (in %) in Spain?
Keep it short and to the point. -3.98. In the year 2006, what is the difference between the Revenue generated (in %) of Dominican Republic and Revenue generated (in %) of Malaysia?
Offer a terse response. -1.74. In the year 2006, what is the difference between the Revenue generated (in %) of Dominican Republic and Revenue generated (in %) of Oman?
Offer a terse response. 7.24. In the year 2006, what is the difference between the Revenue generated (in %) in Dominican Republic and Revenue generated (in %) in Spain?
Your answer should be very brief. 3.6. In the year 2006, what is the difference between the Revenue generated (in %) of Malaysia and Revenue generated (in %) of Oman?
Make the answer very short. 8.98. In the year 2006, what is the difference between the Revenue generated (in %) of Malaysia and Revenue generated (in %) of Spain?
Your answer should be very brief. 5.34. In the year 2006, what is the difference between the Revenue generated (in %) of Oman and Revenue generated (in %) of Spain?
Make the answer very short. -3.64. In the year 2007, what is the difference between the Revenue generated (in %) of Dominican Republic and Revenue generated (in %) of Malaysia?
Ensure brevity in your answer.  -2.4. In the year 2007, what is the difference between the Revenue generated (in %) of Dominican Republic and Revenue generated (in %) of Oman?
Keep it short and to the point. 5.5. In the year 2007, what is the difference between the Revenue generated (in %) in Dominican Republic and Revenue generated (in %) in Spain?
Keep it short and to the point. 2.4. In the year 2007, what is the difference between the Revenue generated (in %) in Malaysia and Revenue generated (in %) in Oman?
Provide a succinct answer. 7.9. In the year 2007, what is the difference between the Revenue generated (in %) in Malaysia and Revenue generated (in %) in Spain?
Your answer should be compact. 4.8. In the year 2007, what is the difference between the Revenue generated (in %) of Oman and Revenue generated (in %) of Spain?
Ensure brevity in your answer.  -3.1. In the year 2008, what is the difference between the Revenue generated (in %) of Dominican Republic and Revenue generated (in %) of Malaysia?
Your response must be concise. 1.68. In the year 2008, what is the difference between the Revenue generated (in %) of Dominican Republic and Revenue generated (in %) of Oman?
Offer a terse response. 9.02. In the year 2008, what is the difference between the Revenue generated (in %) of Dominican Republic and Revenue generated (in %) of Spain?
Provide a short and direct response. 4.84. In the year 2008, what is the difference between the Revenue generated (in %) of Malaysia and Revenue generated (in %) of Oman?
Give a very brief answer. 7.34. In the year 2008, what is the difference between the Revenue generated (in %) in Malaysia and Revenue generated (in %) in Spain?
Offer a terse response. 3.16. In the year 2008, what is the difference between the Revenue generated (in %) in Oman and Revenue generated (in %) in Spain?
Provide a short and direct response. -4.17. In the year 2009, what is the difference between the Revenue generated (in %) of Dominican Republic and Revenue generated (in %) of Malaysia?
Provide a short and direct response. 3.92. In the year 2009, what is the difference between the Revenue generated (in %) of Dominican Republic and Revenue generated (in %) of Oman?
Your response must be concise. 12.22. In the year 2009, what is the difference between the Revenue generated (in %) in Dominican Republic and Revenue generated (in %) in Spain?
Ensure brevity in your answer.  6.77. In the year 2009, what is the difference between the Revenue generated (in %) of Malaysia and Revenue generated (in %) of Oman?
Offer a very short reply. 8.3. In the year 2009, what is the difference between the Revenue generated (in %) in Malaysia and Revenue generated (in %) in Spain?
Ensure brevity in your answer.  2.85. In the year 2009, what is the difference between the Revenue generated (in %) of Oman and Revenue generated (in %) of Spain?
Provide a succinct answer. -5.45. In the year 2010, what is the difference between the Revenue generated (in %) of Dominican Republic and Revenue generated (in %) of Malaysia?
Provide a short and direct response. 2.73. In the year 2010, what is the difference between the Revenue generated (in %) in Dominican Republic and Revenue generated (in %) in Oman?
Your answer should be very brief. 12.04. In the year 2010, what is the difference between the Revenue generated (in %) of Dominican Republic and Revenue generated (in %) of Spain?
Offer a terse response. 6.68. In the year 2010, what is the difference between the Revenue generated (in %) in Malaysia and Revenue generated (in %) in Oman?
Your answer should be compact. 9.31. In the year 2010, what is the difference between the Revenue generated (in %) in Malaysia and Revenue generated (in %) in Spain?
Your answer should be compact. 3.95. In the year 2010, what is the difference between the Revenue generated (in %) of Oman and Revenue generated (in %) of Spain?
Provide a succinct answer. -5.36. In the year 2011, what is the difference between the Revenue generated (in %) in Dominican Republic and Revenue generated (in %) in Malaysia?
Provide a short and direct response. 4.54. In the year 2011, what is the difference between the Revenue generated (in %) of Dominican Republic and Revenue generated (in %) of Oman?
Your answer should be compact. 13.74. In the year 2011, what is the difference between the Revenue generated (in %) of Dominican Republic and Revenue generated (in %) of Spain?
Keep it short and to the point. 6.63. In the year 2011, what is the difference between the Revenue generated (in %) in Malaysia and Revenue generated (in %) in Oman?
Provide a short and direct response. 9.19. In the year 2011, what is the difference between the Revenue generated (in %) of Malaysia and Revenue generated (in %) of Spain?
Your response must be concise. 2.08. In the year 2011, what is the difference between the Revenue generated (in %) in Oman and Revenue generated (in %) in Spain?
Offer a terse response. -7.11. What is the ratio of the Revenue generated (in %) of Dominican Republic in 2004 to that in 2005?
Offer a terse response. 1.53. What is the ratio of the Revenue generated (in %) in Oman in 2004 to that in 2005?
Your response must be concise. 1.23. What is the ratio of the Revenue generated (in %) in Spain in 2004 to that in 2005?
Your answer should be compact. 1.19. What is the ratio of the Revenue generated (in %) in Dominican Republic in 2004 to that in 2006?
Your answer should be compact. 1.39. What is the ratio of the Revenue generated (in %) in Malaysia in 2004 to that in 2006?
Offer a very short reply. 1.09. What is the ratio of the Revenue generated (in %) in Oman in 2004 to that in 2006?
Provide a succinct answer. 1.64. What is the ratio of the Revenue generated (in %) of Spain in 2004 to that in 2006?
Give a very brief answer. 1.36. What is the ratio of the Revenue generated (in %) of Dominican Republic in 2004 to that in 2007?
Your answer should be compact. 1.71. What is the ratio of the Revenue generated (in %) in Malaysia in 2004 to that in 2007?
Give a very brief answer. 1.19. What is the ratio of the Revenue generated (in %) in Oman in 2004 to that in 2007?
Provide a short and direct response. 1.39. What is the ratio of the Revenue generated (in %) in Spain in 2004 to that in 2007?
Your answer should be compact. 1.47. What is the ratio of the Revenue generated (in %) in Dominican Republic in 2004 to that in 2008?
Offer a very short reply. 1.2. What is the ratio of the Revenue generated (in %) of Malaysia in 2004 to that in 2008?
Make the answer very short. 1.37. What is the ratio of the Revenue generated (in %) in Oman in 2004 to that in 2008?
Your response must be concise. 2.77. What is the ratio of the Revenue generated (in %) in Spain in 2004 to that in 2008?
Your answer should be compact. 1.34. What is the ratio of the Revenue generated (in %) of Dominican Republic in 2004 to that in 2009?
Make the answer very short. 0.91. What is the ratio of the Revenue generated (in %) in Malaysia in 2004 to that in 2009?
Your answer should be very brief. 1.23. What is the ratio of the Revenue generated (in %) of Oman in 2004 to that in 2009?
Your response must be concise. 2.79. What is the ratio of the Revenue generated (in %) in Spain in 2004 to that in 2009?
Your answer should be compact. 1.06. What is the ratio of the Revenue generated (in %) in Dominican Republic in 2004 to that in 2010?
Provide a succinct answer. 0.93. What is the ratio of the Revenue generated (in %) in Malaysia in 2004 to that in 2010?
Provide a short and direct response. 1.12. What is the ratio of the Revenue generated (in %) in Oman in 2004 to that in 2010?
Your answer should be very brief. 3.9. What is the ratio of the Revenue generated (in %) in Spain in 2004 to that in 2010?
Provide a short and direct response. 1.11. What is the ratio of the Revenue generated (in %) of Dominican Republic in 2004 to that in 2011?
Offer a terse response. 0.83. What is the ratio of the Revenue generated (in %) of Malaysia in 2004 to that in 2011?
Offer a terse response. 1.15. What is the ratio of the Revenue generated (in %) in Oman in 2004 to that in 2011?
Your answer should be compact. 5.15. What is the ratio of the Revenue generated (in %) in Spain in 2004 to that in 2011?
Keep it short and to the point. 0.87. What is the ratio of the Revenue generated (in %) of Dominican Republic in 2005 to that in 2006?
Keep it short and to the point. 0.91. What is the ratio of the Revenue generated (in %) in Malaysia in 2005 to that in 2006?
Offer a very short reply. 1.08. What is the ratio of the Revenue generated (in %) of Oman in 2005 to that in 2006?
Offer a terse response. 1.33. What is the ratio of the Revenue generated (in %) in Spain in 2005 to that in 2006?
Make the answer very short. 1.15. What is the ratio of the Revenue generated (in %) in Dominican Republic in 2005 to that in 2007?
Your answer should be compact. 1.12. What is the ratio of the Revenue generated (in %) of Malaysia in 2005 to that in 2007?
Make the answer very short. 1.18. What is the ratio of the Revenue generated (in %) in Oman in 2005 to that in 2007?
Make the answer very short. 1.13. What is the ratio of the Revenue generated (in %) of Spain in 2005 to that in 2007?
Your answer should be compact. 1.24. What is the ratio of the Revenue generated (in %) of Dominican Republic in 2005 to that in 2008?
Give a very brief answer. 0.79. What is the ratio of the Revenue generated (in %) in Malaysia in 2005 to that in 2008?
Keep it short and to the point. 1.36. What is the ratio of the Revenue generated (in %) of Oman in 2005 to that in 2008?
Make the answer very short. 2.24. What is the ratio of the Revenue generated (in %) of Spain in 2005 to that in 2008?
Provide a short and direct response. 1.13. What is the ratio of the Revenue generated (in %) of Dominican Republic in 2005 to that in 2009?
Give a very brief answer. 0.59. What is the ratio of the Revenue generated (in %) of Malaysia in 2005 to that in 2009?
Your response must be concise. 1.22. What is the ratio of the Revenue generated (in %) in Oman in 2005 to that in 2009?
Give a very brief answer. 2.26. What is the ratio of the Revenue generated (in %) in Spain in 2005 to that in 2009?
Your response must be concise. 0.9. What is the ratio of the Revenue generated (in %) in Dominican Republic in 2005 to that in 2010?
Provide a short and direct response. 0.61. What is the ratio of the Revenue generated (in %) in Malaysia in 2005 to that in 2010?
Keep it short and to the point. 1.12. What is the ratio of the Revenue generated (in %) of Oman in 2005 to that in 2010?
Your response must be concise. 3.17. What is the ratio of the Revenue generated (in %) of Spain in 2005 to that in 2010?
Make the answer very short. 0.94. What is the ratio of the Revenue generated (in %) of Dominican Republic in 2005 to that in 2011?
Provide a succinct answer. 0.54. What is the ratio of the Revenue generated (in %) of Malaysia in 2005 to that in 2011?
Provide a succinct answer. 1.14. What is the ratio of the Revenue generated (in %) of Oman in 2005 to that in 2011?
Make the answer very short. 4.18. What is the ratio of the Revenue generated (in %) in Spain in 2005 to that in 2011?
Keep it short and to the point. 0.73. What is the ratio of the Revenue generated (in %) in Dominican Republic in 2006 to that in 2007?
Keep it short and to the point. 1.23. What is the ratio of the Revenue generated (in %) of Malaysia in 2006 to that in 2007?
Your answer should be very brief. 1.1. What is the ratio of the Revenue generated (in %) in Oman in 2006 to that in 2007?
Your response must be concise. 0.85. What is the ratio of the Revenue generated (in %) in Spain in 2006 to that in 2007?
Provide a succinct answer. 1.08. What is the ratio of the Revenue generated (in %) in Dominican Republic in 2006 to that in 2008?
Make the answer very short. 0.86. What is the ratio of the Revenue generated (in %) in Malaysia in 2006 to that in 2008?
Keep it short and to the point. 1.26. What is the ratio of the Revenue generated (in %) of Oman in 2006 to that in 2008?
Your response must be concise. 1.69. What is the ratio of the Revenue generated (in %) of Spain in 2006 to that in 2008?
Offer a terse response. 0.99. What is the ratio of the Revenue generated (in %) of Dominican Republic in 2006 to that in 2009?
Offer a terse response. 0.65. What is the ratio of the Revenue generated (in %) of Malaysia in 2006 to that in 2009?
Make the answer very short. 1.13. What is the ratio of the Revenue generated (in %) of Oman in 2006 to that in 2009?
Offer a terse response. 1.7. What is the ratio of the Revenue generated (in %) in Spain in 2006 to that in 2009?
Offer a terse response. 0.78. What is the ratio of the Revenue generated (in %) of Dominican Republic in 2006 to that in 2010?
Provide a short and direct response. 0.67. What is the ratio of the Revenue generated (in %) of Malaysia in 2006 to that in 2010?
Make the answer very short. 1.03. What is the ratio of the Revenue generated (in %) of Oman in 2006 to that in 2010?
Your response must be concise. 2.38. What is the ratio of the Revenue generated (in %) of Spain in 2006 to that in 2010?
Give a very brief answer. 0.82. What is the ratio of the Revenue generated (in %) in Dominican Republic in 2006 to that in 2011?
Give a very brief answer. 0.59. What is the ratio of the Revenue generated (in %) of Malaysia in 2006 to that in 2011?
Keep it short and to the point. 1.06. What is the ratio of the Revenue generated (in %) in Oman in 2006 to that in 2011?
Your response must be concise. 3.14. What is the ratio of the Revenue generated (in %) of Spain in 2006 to that in 2011?
Keep it short and to the point. 0.64. What is the ratio of the Revenue generated (in %) in Dominican Republic in 2007 to that in 2008?
Give a very brief answer. 0.7. What is the ratio of the Revenue generated (in %) of Malaysia in 2007 to that in 2008?
Ensure brevity in your answer.  1.15. What is the ratio of the Revenue generated (in %) in Oman in 2007 to that in 2008?
Offer a terse response. 1.99. What is the ratio of the Revenue generated (in %) in Spain in 2007 to that in 2008?
Give a very brief answer. 0.91. What is the ratio of the Revenue generated (in %) of Dominican Republic in 2007 to that in 2009?
Offer a very short reply. 0.53. What is the ratio of the Revenue generated (in %) in Malaysia in 2007 to that in 2009?
Your answer should be compact. 1.03. What is the ratio of the Revenue generated (in %) of Oman in 2007 to that in 2009?
Your answer should be compact. 2. What is the ratio of the Revenue generated (in %) in Spain in 2007 to that in 2009?
Provide a short and direct response. 0.72. What is the ratio of the Revenue generated (in %) in Dominican Republic in 2007 to that in 2010?
Your response must be concise. 0.55. What is the ratio of the Revenue generated (in %) in Malaysia in 2007 to that in 2010?
Give a very brief answer. 0.94. What is the ratio of the Revenue generated (in %) of Oman in 2007 to that in 2010?
Keep it short and to the point. 2.8. What is the ratio of the Revenue generated (in %) of Spain in 2007 to that in 2010?
Provide a short and direct response. 0.76. What is the ratio of the Revenue generated (in %) in Dominican Republic in 2007 to that in 2011?
Your response must be concise. 0.48. What is the ratio of the Revenue generated (in %) in Oman in 2007 to that in 2011?
Ensure brevity in your answer.  3.7. What is the ratio of the Revenue generated (in %) of Spain in 2007 to that in 2011?
Keep it short and to the point. 0.59. What is the ratio of the Revenue generated (in %) in Dominican Republic in 2008 to that in 2009?
Offer a terse response. 0.75. What is the ratio of the Revenue generated (in %) of Malaysia in 2008 to that in 2009?
Offer a terse response. 0.89. What is the ratio of the Revenue generated (in %) in Oman in 2008 to that in 2009?
Offer a very short reply. 1.01. What is the ratio of the Revenue generated (in %) of Spain in 2008 to that in 2009?
Ensure brevity in your answer.  0.79. What is the ratio of the Revenue generated (in %) of Dominican Republic in 2008 to that in 2010?
Your response must be concise. 0.77. What is the ratio of the Revenue generated (in %) of Malaysia in 2008 to that in 2010?
Your answer should be compact. 0.82. What is the ratio of the Revenue generated (in %) of Oman in 2008 to that in 2010?
Ensure brevity in your answer.  1.41. What is the ratio of the Revenue generated (in %) in Spain in 2008 to that in 2010?
Provide a short and direct response. 0.83. What is the ratio of the Revenue generated (in %) of Dominican Republic in 2008 to that in 2011?
Your answer should be very brief. 0.69. What is the ratio of the Revenue generated (in %) in Malaysia in 2008 to that in 2011?
Keep it short and to the point. 0.84. What is the ratio of the Revenue generated (in %) in Oman in 2008 to that in 2011?
Your response must be concise. 1.86. What is the ratio of the Revenue generated (in %) in Spain in 2008 to that in 2011?
Your response must be concise. 0.65. What is the ratio of the Revenue generated (in %) of Dominican Republic in 2009 to that in 2010?
Ensure brevity in your answer.  1.03. What is the ratio of the Revenue generated (in %) of Malaysia in 2009 to that in 2010?
Make the answer very short. 0.92. What is the ratio of the Revenue generated (in %) of Oman in 2009 to that in 2010?
Offer a very short reply. 1.4. What is the ratio of the Revenue generated (in %) in Spain in 2009 to that in 2010?
Provide a short and direct response. 1.05. What is the ratio of the Revenue generated (in %) of Dominican Republic in 2009 to that in 2011?
Offer a very short reply. 0.91. What is the ratio of the Revenue generated (in %) of Malaysia in 2009 to that in 2011?
Your answer should be compact. 0.94. What is the ratio of the Revenue generated (in %) of Oman in 2009 to that in 2011?
Provide a succinct answer. 1.85. What is the ratio of the Revenue generated (in %) of Spain in 2009 to that in 2011?
Your answer should be very brief. 0.82. What is the ratio of the Revenue generated (in %) in Dominican Republic in 2010 to that in 2011?
Offer a very short reply. 0.89. What is the ratio of the Revenue generated (in %) of Malaysia in 2010 to that in 2011?
Give a very brief answer. 1.02. What is the ratio of the Revenue generated (in %) in Oman in 2010 to that in 2011?
Give a very brief answer. 1.32. What is the ratio of the Revenue generated (in %) of Spain in 2010 to that in 2011?
Your answer should be compact. 0.78. What is the difference between the highest and the second highest Revenue generated (in %) of Dominican Republic?
Ensure brevity in your answer.  1.21. What is the difference between the highest and the second highest Revenue generated (in %) of Malaysia?
Keep it short and to the point. 0.07. What is the difference between the highest and the second highest Revenue generated (in %) of Oman?
Ensure brevity in your answer.  0.35. What is the difference between the highest and the second highest Revenue generated (in %) of Spain?
Keep it short and to the point. 0.97. What is the difference between the highest and the lowest Revenue generated (in %) in Dominican Republic?
Offer a terse response. 7.27. What is the difference between the highest and the lowest Revenue generated (in %) in Malaysia?
Make the answer very short. 2.98. What is the difference between the highest and the lowest Revenue generated (in %) in Oman?
Make the answer very short. 1.49. What is the difference between the highest and the lowest Revenue generated (in %) of Spain?
Keep it short and to the point. 3.04. 